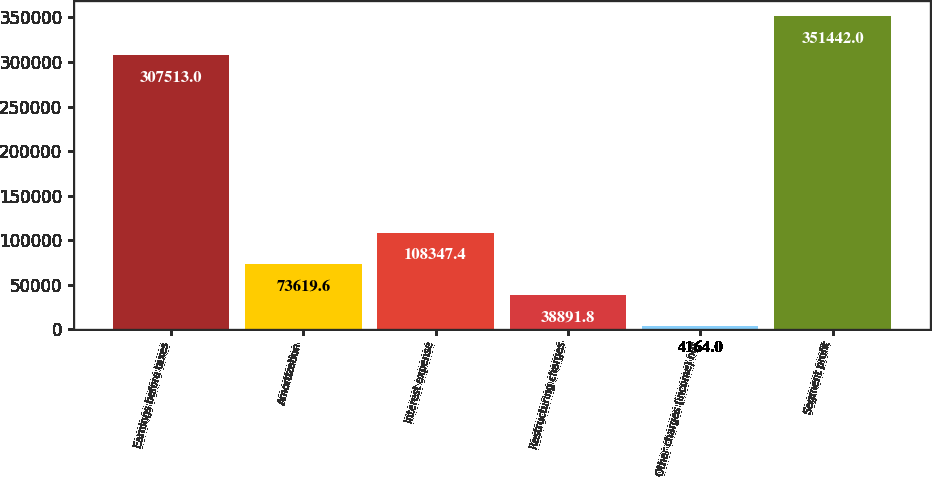<chart> <loc_0><loc_0><loc_500><loc_500><bar_chart><fcel>Earnings before taxes<fcel>Amortization<fcel>Interest expense<fcel>Restructuring charges<fcel>Other charges (income) net<fcel>Segment profit<nl><fcel>307513<fcel>73619.6<fcel>108347<fcel>38891.8<fcel>4164<fcel>351442<nl></chart> 